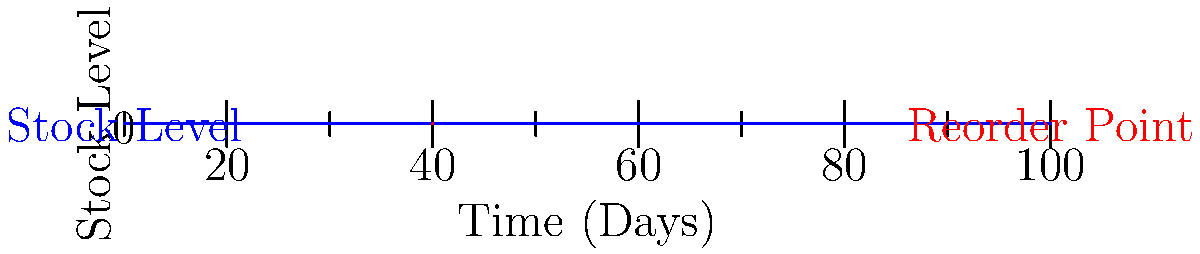Based on the line graph showing stock levels and reorder points over time, how many times did the stock level drop below the reorder point before a new order was placed? To answer this question, we need to analyze the graph step-by-step:

1. Identify the reorder point: The red dashed line represents the reorder point, which is constant at 40 units.

2. Observe the stock level (blue line) over time:
   - The stock level starts at 100 units and gradually decreases.
   - It crosses the reorder point (40 units) for the first time around day 6.
   - The stock level continues to decrease until it reaches 10 units around day 10.
   - At this point, we see a sudden increase in stock level back to 80 units, indicating a new order was placed and received.

3. Count the occurrences:
   - The stock level dropped below the reorder point only once (around day 6) before the new order was placed (around day 10).
   - After the new order, the stock level starts decreasing again but doesn't drop below the reorder point within the timeframe shown in the graph.

Therefore, the stock level dropped below the reorder point only once before a new order was placed.
Answer: 1 time 